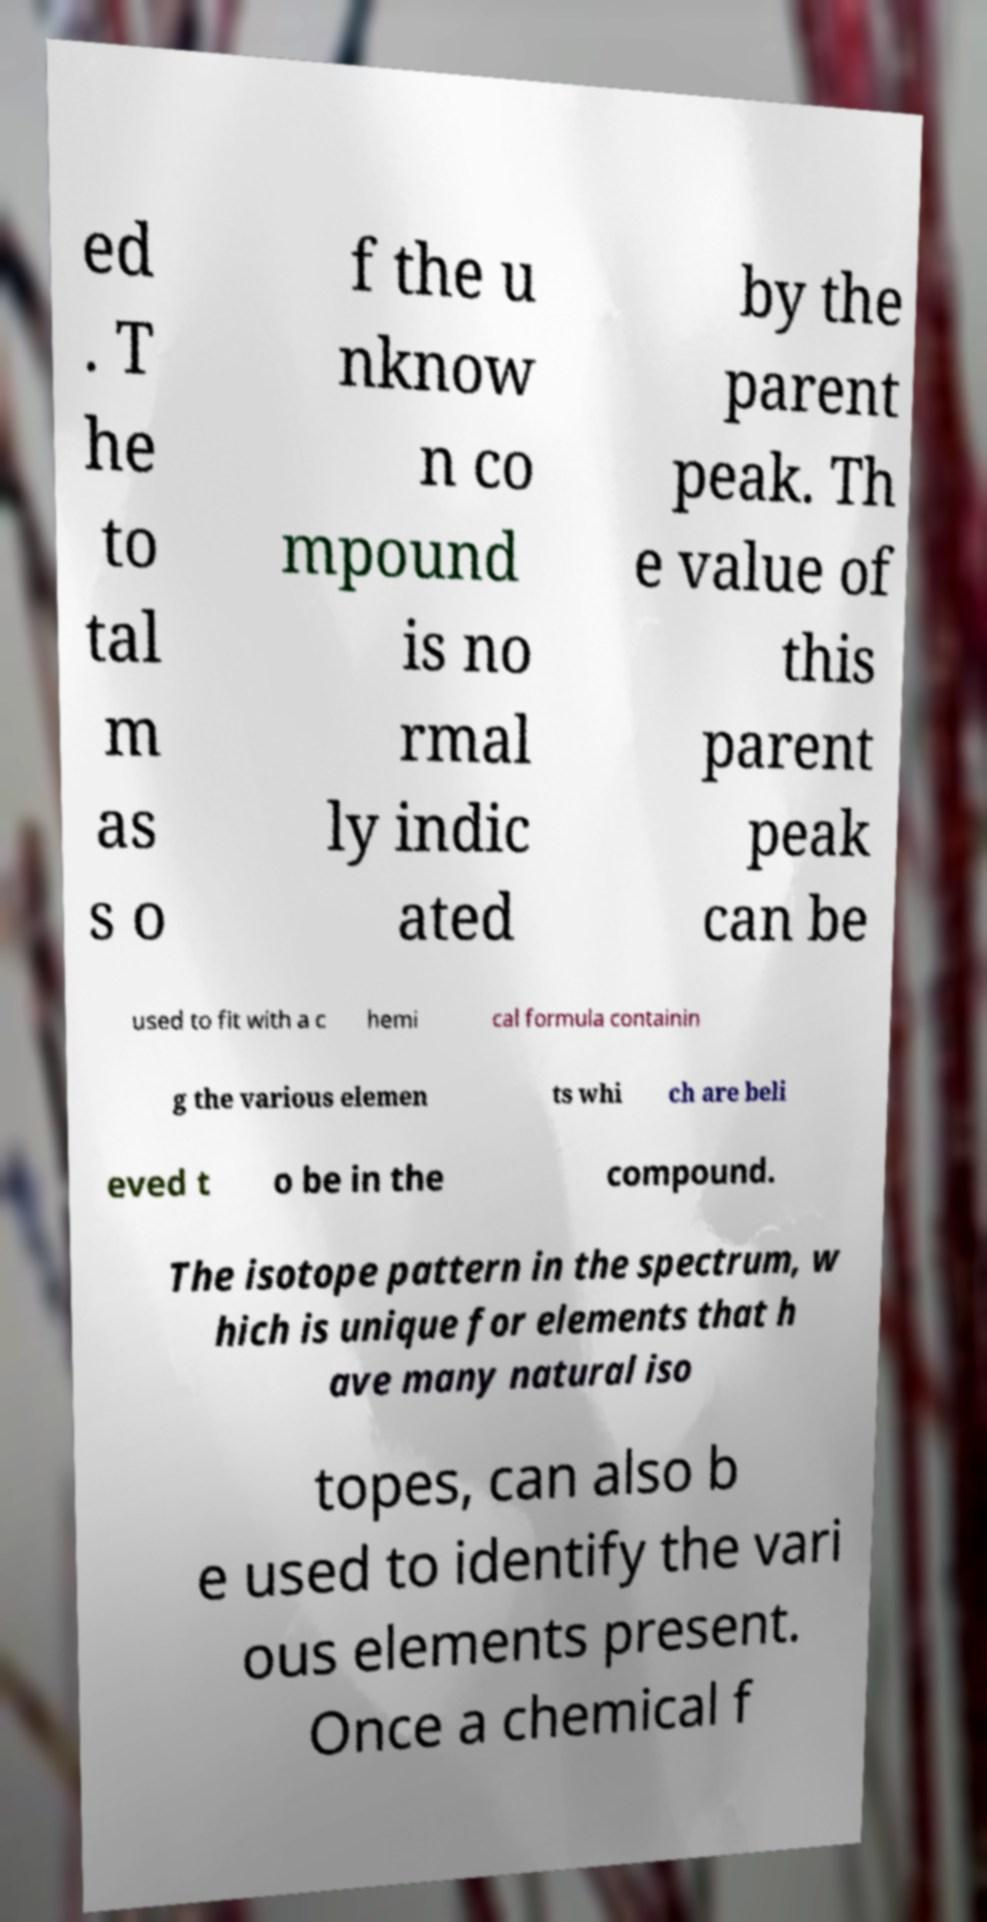Can you accurately transcribe the text from the provided image for me? ed . T he to tal m as s o f the u nknow n co mpound is no rmal ly indic ated by the parent peak. Th e value of this parent peak can be used to fit with a c hemi cal formula containin g the various elemen ts whi ch are beli eved t o be in the compound. The isotope pattern in the spectrum, w hich is unique for elements that h ave many natural iso topes, can also b e used to identify the vari ous elements present. Once a chemical f 